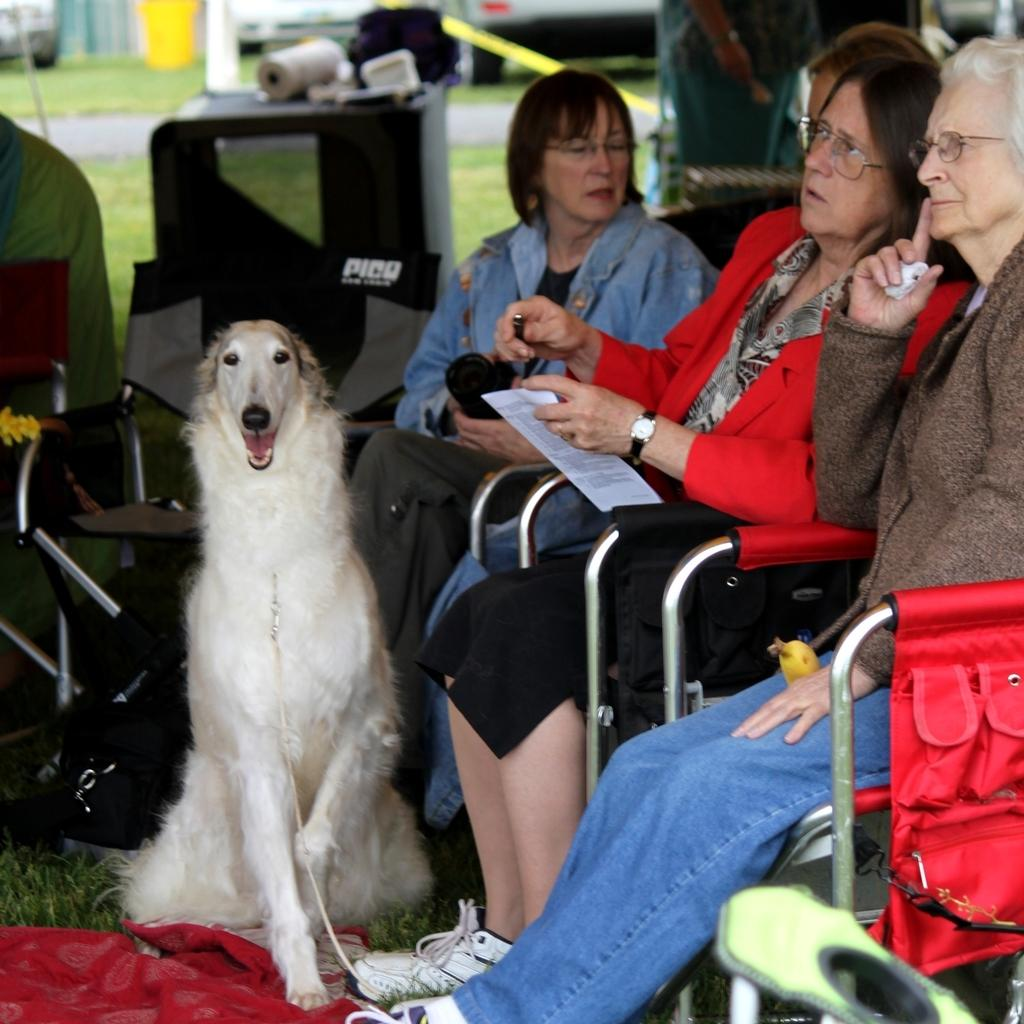How many women are in the image? There are three women in the image. What are the women doing in the image? The women are sitting on chairs and holding papers in their hands. What is in front of the women? There is a dog in front of the women. What can be seen in the background of the image? There is grass, a roller, and a stick in the background of the image. What type of offer is the woman in the middle making to the dog in the image? There is no offer being made in the image; the women are holding papers and there is a dog in front of them, but no interaction or offer is depicted. 